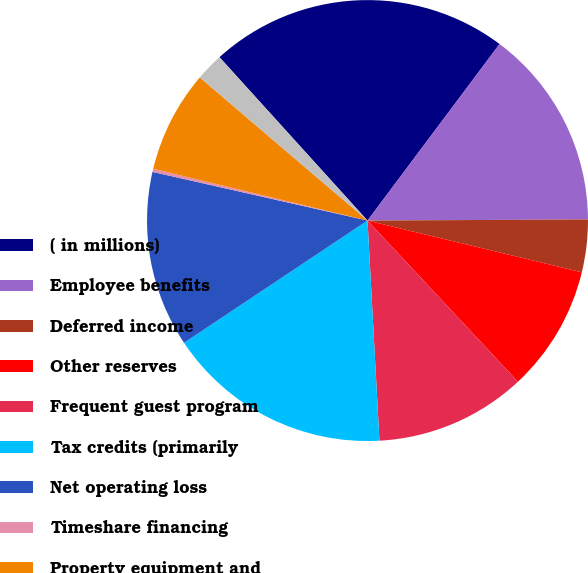Convert chart. <chart><loc_0><loc_0><loc_500><loc_500><pie_chart><fcel>( in millions)<fcel>Employee benefits<fcel>Deferred income<fcel>Other reserves<fcel>Frequent guest program<fcel>Tax credits (primarily<fcel>Net operating loss<fcel>Timeshare financing<fcel>Property equipment and<fcel>Other net<nl><fcel>21.94%<fcel>14.7%<fcel>3.85%<fcel>9.28%<fcel>11.09%<fcel>16.51%<fcel>12.9%<fcel>0.23%<fcel>7.47%<fcel>2.04%<nl></chart> 